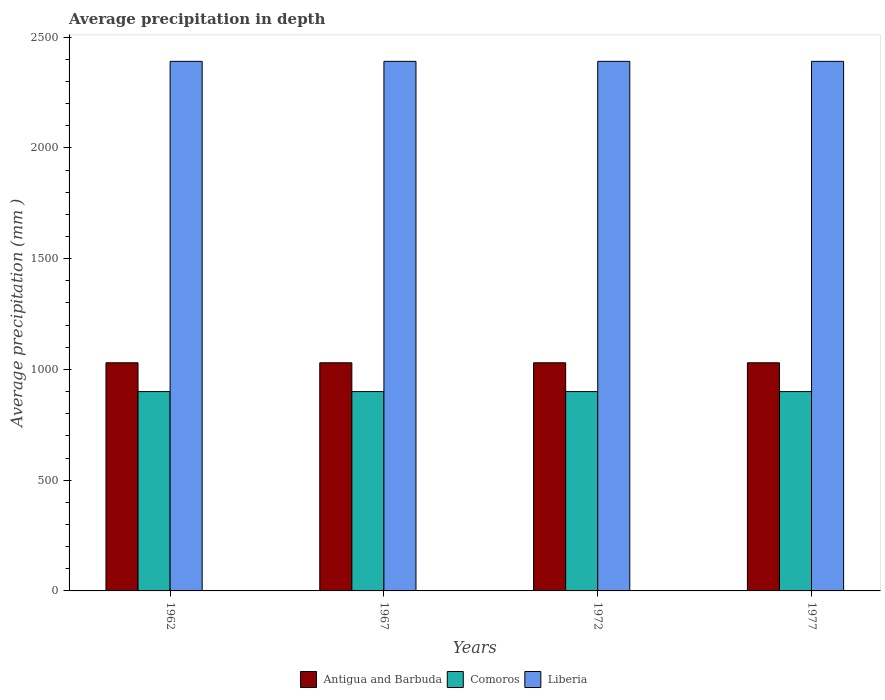How many different coloured bars are there?
Keep it short and to the point. 3. How many groups of bars are there?
Offer a terse response. 4. Are the number of bars per tick equal to the number of legend labels?
Ensure brevity in your answer.  Yes. How many bars are there on the 1st tick from the left?
Your answer should be very brief. 3. What is the label of the 2nd group of bars from the left?
Your response must be concise. 1967. What is the average precipitation in Comoros in 1977?
Provide a succinct answer. 900. Across all years, what is the maximum average precipitation in Liberia?
Keep it short and to the point. 2391. Across all years, what is the minimum average precipitation in Liberia?
Provide a short and direct response. 2391. In which year was the average precipitation in Comoros maximum?
Provide a succinct answer. 1962. What is the total average precipitation in Comoros in the graph?
Provide a short and direct response. 3600. What is the difference between the average precipitation in Comoros in 1962 and the average precipitation in Antigua and Barbuda in 1967?
Keep it short and to the point. -130. What is the average average precipitation in Antigua and Barbuda per year?
Your answer should be very brief. 1030. In the year 1972, what is the difference between the average precipitation in Antigua and Barbuda and average precipitation in Liberia?
Give a very brief answer. -1361. Is the average precipitation in Comoros in 1962 less than that in 1977?
Offer a terse response. No. Is the difference between the average precipitation in Antigua and Barbuda in 1972 and 1977 greater than the difference between the average precipitation in Liberia in 1972 and 1977?
Provide a succinct answer. No. What is the difference between the highest and the second highest average precipitation in Comoros?
Provide a succinct answer. 0. What does the 1st bar from the left in 1977 represents?
Your response must be concise. Antigua and Barbuda. What does the 3rd bar from the right in 1972 represents?
Ensure brevity in your answer.  Antigua and Barbuda. Is it the case that in every year, the sum of the average precipitation in Comoros and average precipitation in Antigua and Barbuda is greater than the average precipitation in Liberia?
Ensure brevity in your answer.  No. Are all the bars in the graph horizontal?
Provide a short and direct response. No. What is the difference between two consecutive major ticks on the Y-axis?
Keep it short and to the point. 500. Does the graph contain any zero values?
Provide a short and direct response. No. Does the graph contain grids?
Offer a very short reply. No. Where does the legend appear in the graph?
Your response must be concise. Bottom center. How are the legend labels stacked?
Your answer should be very brief. Horizontal. What is the title of the graph?
Offer a very short reply. Average precipitation in depth. What is the label or title of the X-axis?
Keep it short and to the point. Years. What is the label or title of the Y-axis?
Offer a very short reply. Average precipitation (mm ). What is the Average precipitation (mm ) in Antigua and Barbuda in 1962?
Your answer should be very brief. 1030. What is the Average precipitation (mm ) in Comoros in 1962?
Offer a very short reply. 900. What is the Average precipitation (mm ) in Liberia in 1962?
Keep it short and to the point. 2391. What is the Average precipitation (mm ) of Antigua and Barbuda in 1967?
Offer a very short reply. 1030. What is the Average precipitation (mm ) of Comoros in 1967?
Ensure brevity in your answer.  900. What is the Average precipitation (mm ) of Liberia in 1967?
Your response must be concise. 2391. What is the Average precipitation (mm ) in Antigua and Barbuda in 1972?
Keep it short and to the point. 1030. What is the Average precipitation (mm ) in Comoros in 1972?
Keep it short and to the point. 900. What is the Average precipitation (mm ) in Liberia in 1972?
Keep it short and to the point. 2391. What is the Average precipitation (mm ) of Antigua and Barbuda in 1977?
Keep it short and to the point. 1030. What is the Average precipitation (mm ) in Comoros in 1977?
Keep it short and to the point. 900. What is the Average precipitation (mm ) in Liberia in 1977?
Keep it short and to the point. 2391. Across all years, what is the maximum Average precipitation (mm ) of Antigua and Barbuda?
Your answer should be compact. 1030. Across all years, what is the maximum Average precipitation (mm ) in Comoros?
Make the answer very short. 900. Across all years, what is the maximum Average precipitation (mm ) in Liberia?
Ensure brevity in your answer.  2391. Across all years, what is the minimum Average precipitation (mm ) of Antigua and Barbuda?
Make the answer very short. 1030. Across all years, what is the minimum Average precipitation (mm ) in Comoros?
Make the answer very short. 900. Across all years, what is the minimum Average precipitation (mm ) in Liberia?
Offer a terse response. 2391. What is the total Average precipitation (mm ) of Antigua and Barbuda in the graph?
Make the answer very short. 4120. What is the total Average precipitation (mm ) in Comoros in the graph?
Your answer should be compact. 3600. What is the total Average precipitation (mm ) of Liberia in the graph?
Your answer should be compact. 9564. What is the difference between the Average precipitation (mm ) in Antigua and Barbuda in 1962 and that in 1967?
Your answer should be very brief. 0. What is the difference between the Average precipitation (mm ) of Antigua and Barbuda in 1962 and that in 1972?
Your answer should be compact. 0. What is the difference between the Average precipitation (mm ) in Comoros in 1962 and that in 1972?
Your answer should be very brief. 0. What is the difference between the Average precipitation (mm ) of Liberia in 1962 and that in 1972?
Make the answer very short. 0. What is the difference between the Average precipitation (mm ) in Comoros in 1967 and that in 1972?
Make the answer very short. 0. What is the difference between the Average precipitation (mm ) of Liberia in 1967 and that in 1972?
Give a very brief answer. 0. What is the difference between the Average precipitation (mm ) in Antigua and Barbuda in 1967 and that in 1977?
Offer a terse response. 0. What is the difference between the Average precipitation (mm ) of Comoros in 1967 and that in 1977?
Offer a terse response. 0. What is the difference between the Average precipitation (mm ) in Liberia in 1967 and that in 1977?
Keep it short and to the point. 0. What is the difference between the Average precipitation (mm ) of Liberia in 1972 and that in 1977?
Provide a succinct answer. 0. What is the difference between the Average precipitation (mm ) of Antigua and Barbuda in 1962 and the Average precipitation (mm ) of Comoros in 1967?
Offer a very short reply. 130. What is the difference between the Average precipitation (mm ) in Antigua and Barbuda in 1962 and the Average precipitation (mm ) in Liberia in 1967?
Your response must be concise. -1361. What is the difference between the Average precipitation (mm ) of Comoros in 1962 and the Average precipitation (mm ) of Liberia in 1967?
Your answer should be compact. -1491. What is the difference between the Average precipitation (mm ) of Antigua and Barbuda in 1962 and the Average precipitation (mm ) of Comoros in 1972?
Offer a very short reply. 130. What is the difference between the Average precipitation (mm ) in Antigua and Barbuda in 1962 and the Average precipitation (mm ) in Liberia in 1972?
Your response must be concise. -1361. What is the difference between the Average precipitation (mm ) of Comoros in 1962 and the Average precipitation (mm ) of Liberia in 1972?
Make the answer very short. -1491. What is the difference between the Average precipitation (mm ) of Antigua and Barbuda in 1962 and the Average precipitation (mm ) of Comoros in 1977?
Offer a terse response. 130. What is the difference between the Average precipitation (mm ) of Antigua and Barbuda in 1962 and the Average precipitation (mm ) of Liberia in 1977?
Your response must be concise. -1361. What is the difference between the Average precipitation (mm ) of Comoros in 1962 and the Average precipitation (mm ) of Liberia in 1977?
Your answer should be compact. -1491. What is the difference between the Average precipitation (mm ) in Antigua and Barbuda in 1967 and the Average precipitation (mm ) in Comoros in 1972?
Offer a terse response. 130. What is the difference between the Average precipitation (mm ) in Antigua and Barbuda in 1967 and the Average precipitation (mm ) in Liberia in 1972?
Offer a very short reply. -1361. What is the difference between the Average precipitation (mm ) of Comoros in 1967 and the Average precipitation (mm ) of Liberia in 1972?
Offer a terse response. -1491. What is the difference between the Average precipitation (mm ) in Antigua and Barbuda in 1967 and the Average precipitation (mm ) in Comoros in 1977?
Provide a succinct answer. 130. What is the difference between the Average precipitation (mm ) in Antigua and Barbuda in 1967 and the Average precipitation (mm ) in Liberia in 1977?
Offer a very short reply. -1361. What is the difference between the Average precipitation (mm ) of Comoros in 1967 and the Average precipitation (mm ) of Liberia in 1977?
Provide a succinct answer. -1491. What is the difference between the Average precipitation (mm ) of Antigua and Barbuda in 1972 and the Average precipitation (mm ) of Comoros in 1977?
Offer a very short reply. 130. What is the difference between the Average precipitation (mm ) in Antigua and Barbuda in 1972 and the Average precipitation (mm ) in Liberia in 1977?
Give a very brief answer. -1361. What is the difference between the Average precipitation (mm ) of Comoros in 1972 and the Average precipitation (mm ) of Liberia in 1977?
Your response must be concise. -1491. What is the average Average precipitation (mm ) in Antigua and Barbuda per year?
Your answer should be very brief. 1030. What is the average Average precipitation (mm ) of Comoros per year?
Your answer should be very brief. 900. What is the average Average precipitation (mm ) in Liberia per year?
Provide a short and direct response. 2391. In the year 1962, what is the difference between the Average precipitation (mm ) of Antigua and Barbuda and Average precipitation (mm ) of Comoros?
Provide a short and direct response. 130. In the year 1962, what is the difference between the Average precipitation (mm ) of Antigua and Barbuda and Average precipitation (mm ) of Liberia?
Provide a short and direct response. -1361. In the year 1962, what is the difference between the Average precipitation (mm ) in Comoros and Average precipitation (mm ) in Liberia?
Give a very brief answer. -1491. In the year 1967, what is the difference between the Average precipitation (mm ) in Antigua and Barbuda and Average precipitation (mm ) in Comoros?
Make the answer very short. 130. In the year 1967, what is the difference between the Average precipitation (mm ) in Antigua and Barbuda and Average precipitation (mm ) in Liberia?
Keep it short and to the point. -1361. In the year 1967, what is the difference between the Average precipitation (mm ) of Comoros and Average precipitation (mm ) of Liberia?
Give a very brief answer. -1491. In the year 1972, what is the difference between the Average precipitation (mm ) of Antigua and Barbuda and Average precipitation (mm ) of Comoros?
Your response must be concise. 130. In the year 1972, what is the difference between the Average precipitation (mm ) in Antigua and Barbuda and Average precipitation (mm ) in Liberia?
Make the answer very short. -1361. In the year 1972, what is the difference between the Average precipitation (mm ) of Comoros and Average precipitation (mm ) of Liberia?
Provide a succinct answer. -1491. In the year 1977, what is the difference between the Average precipitation (mm ) of Antigua and Barbuda and Average precipitation (mm ) of Comoros?
Offer a very short reply. 130. In the year 1977, what is the difference between the Average precipitation (mm ) in Antigua and Barbuda and Average precipitation (mm ) in Liberia?
Your answer should be very brief. -1361. In the year 1977, what is the difference between the Average precipitation (mm ) in Comoros and Average precipitation (mm ) in Liberia?
Your answer should be very brief. -1491. What is the ratio of the Average precipitation (mm ) of Comoros in 1962 to that in 1967?
Give a very brief answer. 1. What is the ratio of the Average precipitation (mm ) of Liberia in 1962 to that in 1967?
Make the answer very short. 1. What is the ratio of the Average precipitation (mm ) of Antigua and Barbuda in 1962 to that in 1972?
Your response must be concise. 1. What is the ratio of the Average precipitation (mm ) in Liberia in 1962 to that in 1972?
Keep it short and to the point. 1. What is the ratio of the Average precipitation (mm ) in Antigua and Barbuda in 1962 to that in 1977?
Keep it short and to the point. 1. What is the ratio of the Average precipitation (mm ) in Liberia in 1962 to that in 1977?
Your answer should be very brief. 1. What is the ratio of the Average precipitation (mm ) of Comoros in 1967 to that in 1972?
Offer a very short reply. 1. What is the ratio of the Average precipitation (mm ) of Comoros in 1967 to that in 1977?
Provide a succinct answer. 1. What is the ratio of the Average precipitation (mm ) of Antigua and Barbuda in 1972 to that in 1977?
Offer a very short reply. 1. What is the ratio of the Average precipitation (mm ) in Liberia in 1972 to that in 1977?
Offer a very short reply. 1. What is the difference between the highest and the lowest Average precipitation (mm ) in Comoros?
Make the answer very short. 0. 